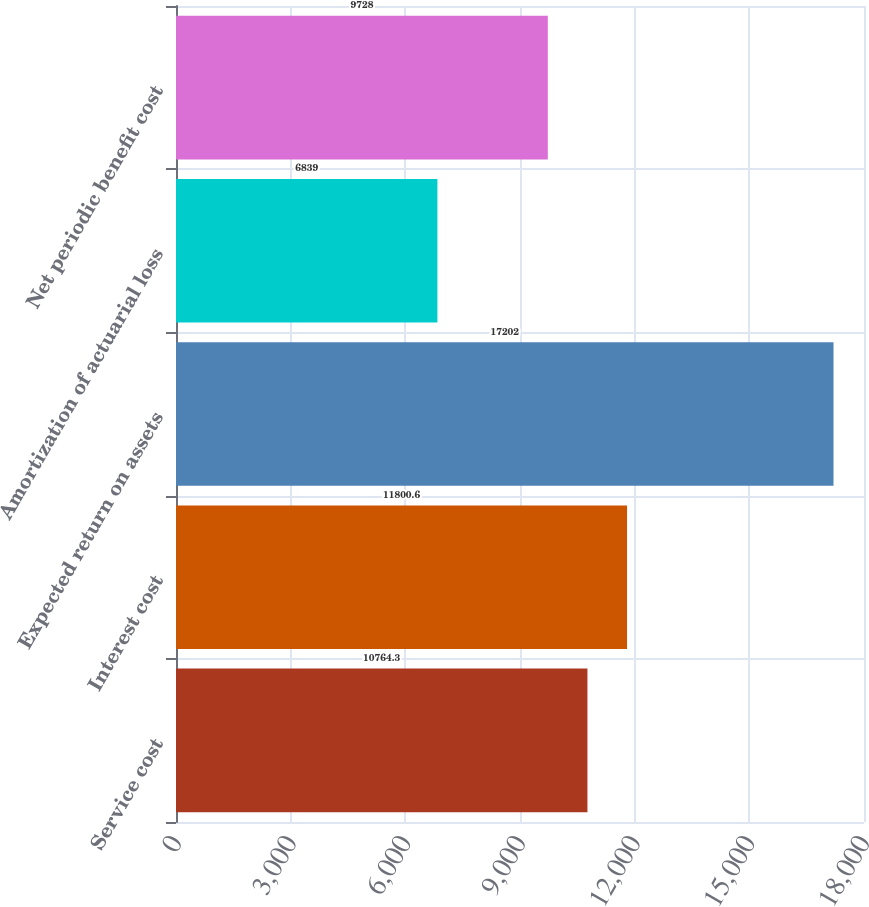<chart> <loc_0><loc_0><loc_500><loc_500><bar_chart><fcel>Service cost<fcel>Interest cost<fcel>Expected return on assets<fcel>Amortization of actuarial loss<fcel>Net periodic benefit cost<nl><fcel>10764.3<fcel>11800.6<fcel>17202<fcel>6839<fcel>9728<nl></chart> 